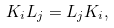<formula> <loc_0><loc_0><loc_500><loc_500>K _ { i } L _ { j } = L _ { j } K _ { i } ,</formula> 